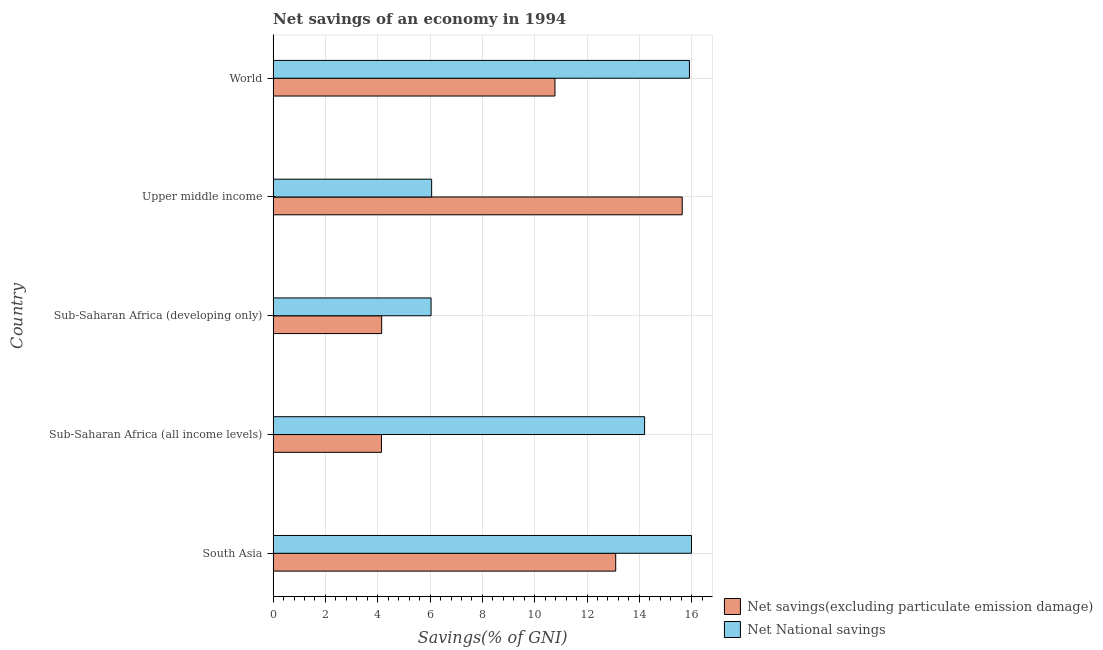Are the number of bars on each tick of the Y-axis equal?
Make the answer very short. Yes. How many bars are there on the 1st tick from the top?
Provide a succinct answer. 2. What is the label of the 3rd group of bars from the top?
Keep it short and to the point. Sub-Saharan Africa (developing only). In how many cases, is the number of bars for a given country not equal to the number of legend labels?
Provide a succinct answer. 0. What is the net savings(excluding particulate emission damage) in Sub-Saharan Africa (developing only)?
Your answer should be very brief. 4.15. Across all countries, what is the maximum net savings(excluding particulate emission damage)?
Offer a terse response. 15.64. Across all countries, what is the minimum net national savings?
Provide a short and direct response. 6.04. In which country was the net national savings minimum?
Make the answer very short. Sub-Saharan Africa (developing only). What is the total net savings(excluding particulate emission damage) in the graph?
Make the answer very short. 47.8. What is the difference between the net savings(excluding particulate emission damage) in South Asia and that in World?
Give a very brief answer. 2.32. What is the difference between the net savings(excluding particulate emission damage) in South Asia and the net national savings in World?
Ensure brevity in your answer.  -2.82. What is the average net national savings per country?
Provide a short and direct response. 11.64. What is the difference between the net national savings and net savings(excluding particulate emission damage) in Upper middle income?
Give a very brief answer. -9.58. What is the ratio of the net savings(excluding particulate emission damage) in South Asia to that in Sub-Saharan Africa (developing only)?
Provide a succinct answer. 3.16. Is the net national savings in Sub-Saharan Africa (all income levels) less than that in Sub-Saharan Africa (developing only)?
Provide a short and direct response. No. What is the difference between the highest and the second highest net savings(excluding particulate emission damage)?
Make the answer very short. 2.54. What is the difference between the highest and the lowest net national savings?
Your answer should be very brief. 9.96. Is the sum of the net savings(excluding particulate emission damage) in Sub-Saharan Africa (developing only) and Upper middle income greater than the maximum net national savings across all countries?
Make the answer very short. Yes. What does the 2nd bar from the top in World represents?
Provide a succinct answer. Net savings(excluding particulate emission damage). What does the 2nd bar from the bottom in Sub-Saharan Africa (developing only) represents?
Keep it short and to the point. Net National savings. How many countries are there in the graph?
Give a very brief answer. 5. What is the difference between two consecutive major ticks on the X-axis?
Provide a short and direct response. 2. Does the graph contain grids?
Your answer should be very brief. Yes. What is the title of the graph?
Your answer should be very brief. Net savings of an economy in 1994. What is the label or title of the X-axis?
Ensure brevity in your answer.  Savings(% of GNI). What is the label or title of the Y-axis?
Your answer should be very brief. Country. What is the Savings(% of GNI) of Net savings(excluding particulate emission damage) in South Asia?
Make the answer very short. 13.1. What is the Savings(% of GNI) in Net National savings in South Asia?
Your answer should be very brief. 15.99. What is the Savings(% of GNI) of Net savings(excluding particulate emission damage) in Sub-Saharan Africa (all income levels)?
Your answer should be very brief. 4.14. What is the Savings(% of GNI) in Net National savings in Sub-Saharan Africa (all income levels)?
Your answer should be compact. 14.2. What is the Savings(% of GNI) in Net savings(excluding particulate emission damage) in Sub-Saharan Africa (developing only)?
Make the answer very short. 4.15. What is the Savings(% of GNI) of Net National savings in Sub-Saharan Africa (developing only)?
Make the answer very short. 6.04. What is the Savings(% of GNI) of Net savings(excluding particulate emission damage) in Upper middle income?
Provide a succinct answer. 15.64. What is the Savings(% of GNI) in Net National savings in Upper middle income?
Give a very brief answer. 6.06. What is the Savings(% of GNI) of Net savings(excluding particulate emission damage) in World?
Ensure brevity in your answer.  10.77. What is the Savings(% of GNI) in Net National savings in World?
Make the answer very short. 15.91. Across all countries, what is the maximum Savings(% of GNI) in Net savings(excluding particulate emission damage)?
Your response must be concise. 15.64. Across all countries, what is the maximum Savings(% of GNI) in Net National savings?
Offer a very short reply. 15.99. Across all countries, what is the minimum Savings(% of GNI) of Net savings(excluding particulate emission damage)?
Provide a succinct answer. 4.14. Across all countries, what is the minimum Savings(% of GNI) in Net National savings?
Keep it short and to the point. 6.04. What is the total Savings(% of GNI) in Net savings(excluding particulate emission damage) in the graph?
Keep it short and to the point. 47.8. What is the total Savings(% of GNI) of Net National savings in the graph?
Your answer should be compact. 58.21. What is the difference between the Savings(% of GNI) of Net savings(excluding particulate emission damage) in South Asia and that in Sub-Saharan Africa (all income levels)?
Keep it short and to the point. 8.96. What is the difference between the Savings(% of GNI) in Net National savings in South Asia and that in Sub-Saharan Africa (all income levels)?
Make the answer very short. 1.79. What is the difference between the Savings(% of GNI) of Net savings(excluding particulate emission damage) in South Asia and that in Sub-Saharan Africa (developing only)?
Keep it short and to the point. 8.95. What is the difference between the Savings(% of GNI) in Net National savings in South Asia and that in Sub-Saharan Africa (developing only)?
Offer a terse response. 9.96. What is the difference between the Savings(% of GNI) of Net savings(excluding particulate emission damage) in South Asia and that in Upper middle income?
Offer a terse response. -2.54. What is the difference between the Savings(% of GNI) in Net National savings in South Asia and that in Upper middle income?
Offer a very short reply. 9.93. What is the difference between the Savings(% of GNI) of Net savings(excluding particulate emission damage) in South Asia and that in World?
Your response must be concise. 2.32. What is the difference between the Savings(% of GNI) in Net National savings in South Asia and that in World?
Your answer should be compact. 0.08. What is the difference between the Savings(% of GNI) of Net savings(excluding particulate emission damage) in Sub-Saharan Africa (all income levels) and that in Sub-Saharan Africa (developing only)?
Your answer should be very brief. -0.01. What is the difference between the Savings(% of GNI) in Net National savings in Sub-Saharan Africa (all income levels) and that in Sub-Saharan Africa (developing only)?
Provide a short and direct response. 8.16. What is the difference between the Savings(% of GNI) in Net savings(excluding particulate emission damage) in Sub-Saharan Africa (all income levels) and that in Upper middle income?
Your answer should be very brief. -11.5. What is the difference between the Savings(% of GNI) in Net National savings in Sub-Saharan Africa (all income levels) and that in Upper middle income?
Your answer should be very brief. 8.14. What is the difference between the Savings(% of GNI) in Net savings(excluding particulate emission damage) in Sub-Saharan Africa (all income levels) and that in World?
Offer a terse response. -6.63. What is the difference between the Savings(% of GNI) of Net National savings in Sub-Saharan Africa (all income levels) and that in World?
Provide a short and direct response. -1.71. What is the difference between the Savings(% of GNI) in Net savings(excluding particulate emission damage) in Sub-Saharan Africa (developing only) and that in Upper middle income?
Offer a very short reply. -11.49. What is the difference between the Savings(% of GNI) of Net National savings in Sub-Saharan Africa (developing only) and that in Upper middle income?
Make the answer very short. -0.02. What is the difference between the Savings(% of GNI) of Net savings(excluding particulate emission damage) in Sub-Saharan Africa (developing only) and that in World?
Ensure brevity in your answer.  -6.62. What is the difference between the Savings(% of GNI) of Net National savings in Sub-Saharan Africa (developing only) and that in World?
Your answer should be compact. -9.88. What is the difference between the Savings(% of GNI) in Net savings(excluding particulate emission damage) in Upper middle income and that in World?
Provide a succinct answer. 4.87. What is the difference between the Savings(% of GNI) in Net National savings in Upper middle income and that in World?
Your response must be concise. -9.85. What is the difference between the Savings(% of GNI) in Net savings(excluding particulate emission damage) in South Asia and the Savings(% of GNI) in Net National savings in Sub-Saharan Africa (all income levels)?
Your answer should be very brief. -1.1. What is the difference between the Savings(% of GNI) of Net savings(excluding particulate emission damage) in South Asia and the Savings(% of GNI) of Net National savings in Sub-Saharan Africa (developing only)?
Give a very brief answer. 7.06. What is the difference between the Savings(% of GNI) of Net savings(excluding particulate emission damage) in South Asia and the Savings(% of GNI) of Net National savings in Upper middle income?
Your answer should be compact. 7.04. What is the difference between the Savings(% of GNI) in Net savings(excluding particulate emission damage) in South Asia and the Savings(% of GNI) in Net National savings in World?
Give a very brief answer. -2.82. What is the difference between the Savings(% of GNI) in Net savings(excluding particulate emission damage) in Sub-Saharan Africa (all income levels) and the Savings(% of GNI) in Net National savings in Sub-Saharan Africa (developing only)?
Give a very brief answer. -1.9. What is the difference between the Savings(% of GNI) of Net savings(excluding particulate emission damage) in Sub-Saharan Africa (all income levels) and the Savings(% of GNI) of Net National savings in Upper middle income?
Ensure brevity in your answer.  -1.92. What is the difference between the Savings(% of GNI) of Net savings(excluding particulate emission damage) in Sub-Saharan Africa (all income levels) and the Savings(% of GNI) of Net National savings in World?
Keep it short and to the point. -11.77. What is the difference between the Savings(% of GNI) in Net savings(excluding particulate emission damage) in Sub-Saharan Africa (developing only) and the Savings(% of GNI) in Net National savings in Upper middle income?
Give a very brief answer. -1.91. What is the difference between the Savings(% of GNI) in Net savings(excluding particulate emission damage) in Sub-Saharan Africa (developing only) and the Savings(% of GNI) in Net National savings in World?
Make the answer very short. -11.77. What is the difference between the Savings(% of GNI) of Net savings(excluding particulate emission damage) in Upper middle income and the Savings(% of GNI) of Net National savings in World?
Keep it short and to the point. -0.28. What is the average Savings(% of GNI) in Net savings(excluding particulate emission damage) per country?
Provide a succinct answer. 9.56. What is the average Savings(% of GNI) in Net National savings per country?
Offer a terse response. 11.64. What is the difference between the Savings(% of GNI) in Net savings(excluding particulate emission damage) and Savings(% of GNI) in Net National savings in South Asia?
Your answer should be compact. -2.9. What is the difference between the Savings(% of GNI) of Net savings(excluding particulate emission damage) and Savings(% of GNI) of Net National savings in Sub-Saharan Africa (all income levels)?
Offer a terse response. -10.06. What is the difference between the Savings(% of GNI) of Net savings(excluding particulate emission damage) and Savings(% of GNI) of Net National savings in Sub-Saharan Africa (developing only)?
Give a very brief answer. -1.89. What is the difference between the Savings(% of GNI) in Net savings(excluding particulate emission damage) and Savings(% of GNI) in Net National savings in Upper middle income?
Keep it short and to the point. 9.58. What is the difference between the Savings(% of GNI) in Net savings(excluding particulate emission damage) and Savings(% of GNI) in Net National savings in World?
Provide a short and direct response. -5.14. What is the ratio of the Savings(% of GNI) of Net savings(excluding particulate emission damage) in South Asia to that in Sub-Saharan Africa (all income levels)?
Offer a terse response. 3.16. What is the ratio of the Savings(% of GNI) of Net National savings in South Asia to that in Sub-Saharan Africa (all income levels)?
Offer a very short reply. 1.13. What is the ratio of the Savings(% of GNI) of Net savings(excluding particulate emission damage) in South Asia to that in Sub-Saharan Africa (developing only)?
Your answer should be compact. 3.16. What is the ratio of the Savings(% of GNI) in Net National savings in South Asia to that in Sub-Saharan Africa (developing only)?
Your answer should be very brief. 2.65. What is the ratio of the Savings(% of GNI) in Net savings(excluding particulate emission damage) in South Asia to that in Upper middle income?
Keep it short and to the point. 0.84. What is the ratio of the Savings(% of GNI) in Net National savings in South Asia to that in Upper middle income?
Keep it short and to the point. 2.64. What is the ratio of the Savings(% of GNI) of Net savings(excluding particulate emission damage) in South Asia to that in World?
Offer a very short reply. 1.22. What is the ratio of the Savings(% of GNI) of Net savings(excluding particulate emission damage) in Sub-Saharan Africa (all income levels) to that in Sub-Saharan Africa (developing only)?
Keep it short and to the point. 1. What is the ratio of the Savings(% of GNI) in Net National savings in Sub-Saharan Africa (all income levels) to that in Sub-Saharan Africa (developing only)?
Your answer should be compact. 2.35. What is the ratio of the Savings(% of GNI) of Net savings(excluding particulate emission damage) in Sub-Saharan Africa (all income levels) to that in Upper middle income?
Keep it short and to the point. 0.26. What is the ratio of the Savings(% of GNI) of Net National savings in Sub-Saharan Africa (all income levels) to that in Upper middle income?
Ensure brevity in your answer.  2.34. What is the ratio of the Savings(% of GNI) of Net savings(excluding particulate emission damage) in Sub-Saharan Africa (all income levels) to that in World?
Your response must be concise. 0.38. What is the ratio of the Savings(% of GNI) in Net National savings in Sub-Saharan Africa (all income levels) to that in World?
Provide a short and direct response. 0.89. What is the ratio of the Savings(% of GNI) in Net savings(excluding particulate emission damage) in Sub-Saharan Africa (developing only) to that in Upper middle income?
Give a very brief answer. 0.27. What is the ratio of the Savings(% of GNI) of Net National savings in Sub-Saharan Africa (developing only) to that in Upper middle income?
Your answer should be very brief. 1. What is the ratio of the Savings(% of GNI) of Net savings(excluding particulate emission damage) in Sub-Saharan Africa (developing only) to that in World?
Your answer should be compact. 0.39. What is the ratio of the Savings(% of GNI) of Net National savings in Sub-Saharan Africa (developing only) to that in World?
Your answer should be compact. 0.38. What is the ratio of the Savings(% of GNI) in Net savings(excluding particulate emission damage) in Upper middle income to that in World?
Give a very brief answer. 1.45. What is the ratio of the Savings(% of GNI) of Net National savings in Upper middle income to that in World?
Provide a succinct answer. 0.38. What is the difference between the highest and the second highest Savings(% of GNI) in Net savings(excluding particulate emission damage)?
Make the answer very short. 2.54. What is the difference between the highest and the second highest Savings(% of GNI) of Net National savings?
Offer a terse response. 0.08. What is the difference between the highest and the lowest Savings(% of GNI) of Net savings(excluding particulate emission damage)?
Your response must be concise. 11.5. What is the difference between the highest and the lowest Savings(% of GNI) in Net National savings?
Ensure brevity in your answer.  9.96. 